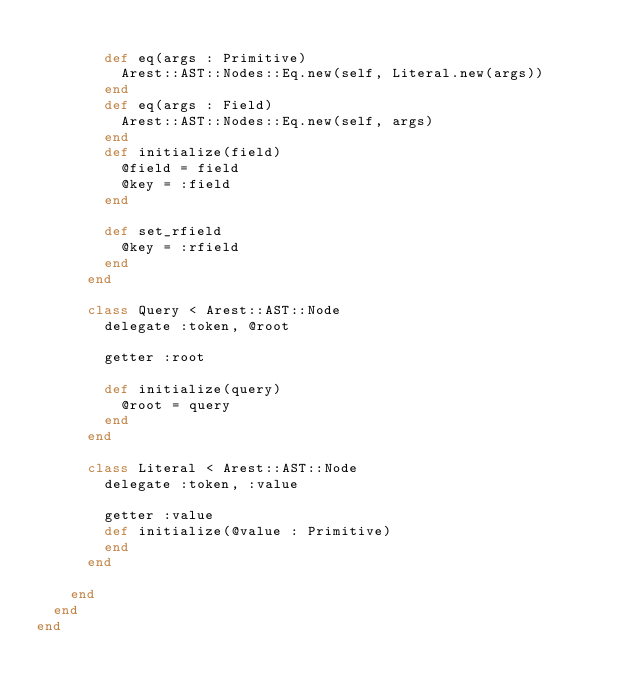<code> <loc_0><loc_0><loc_500><loc_500><_Crystal_>
        def eq(args : Primitive)
          Arest::AST::Nodes::Eq.new(self, Literal.new(args))
        end
        def eq(args : Field)
          Arest::AST::Nodes::Eq.new(self, args)
        end
        def initialize(field)
          @field = field
          @key = :field
        end

        def set_rfield
          @key = :rfield
        end
      end

      class Query < Arest::AST::Node
        delegate :token, @root 

        getter :root

        def initialize(query)
          @root = query
        end
      end

      class Literal < Arest::AST::Node
        delegate :token, :value

        getter :value
        def initialize(@value : Primitive)
        end
      end

    end
  end
end
</code> 